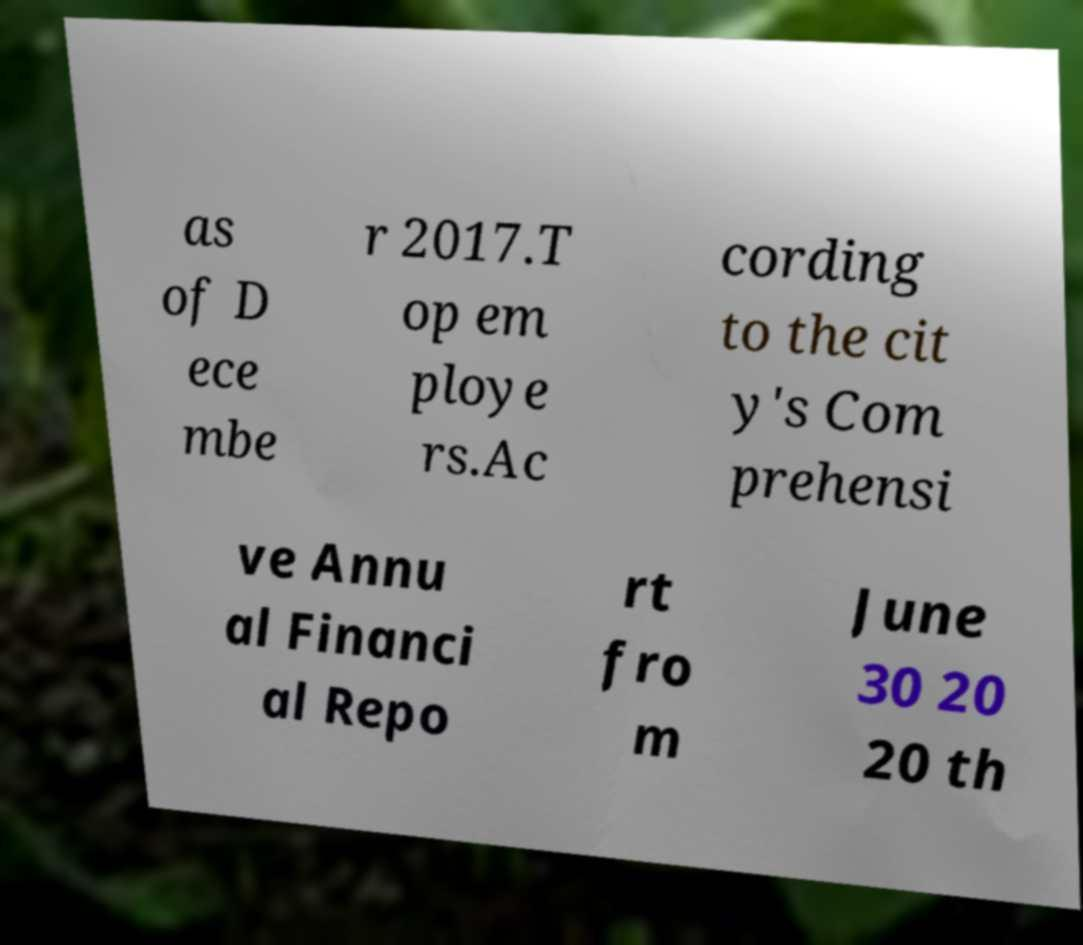Could you extract and type out the text from this image? as of D ece mbe r 2017.T op em ploye rs.Ac cording to the cit y's Com prehensi ve Annu al Financi al Repo rt fro m June 30 20 20 th 